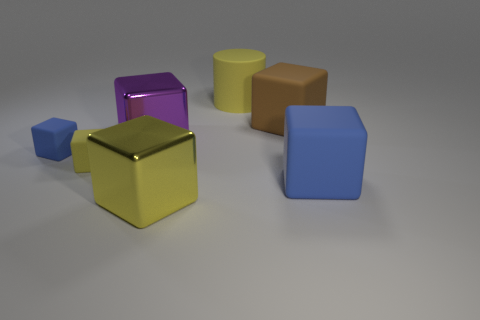Subtract all blue cubes. How many cubes are left? 4 Subtract all large yellow metal blocks. How many blocks are left? 5 Subtract 3 blocks. How many blocks are left? 3 Subtract all red cubes. Subtract all red cylinders. How many cubes are left? 6 Add 2 big blue things. How many objects exist? 9 Subtract all blocks. How many objects are left? 1 Add 4 small green matte objects. How many small green matte objects exist? 4 Subtract 1 yellow blocks. How many objects are left? 6 Subtract all big yellow rubber cylinders. Subtract all blue rubber blocks. How many objects are left? 4 Add 4 tiny matte objects. How many tiny matte objects are left? 6 